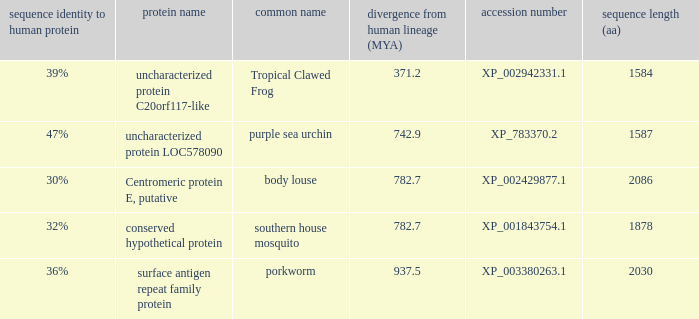What is the protein name of the protein with a sequence identity to human protein of 32%? Conserved hypothetical protein. 